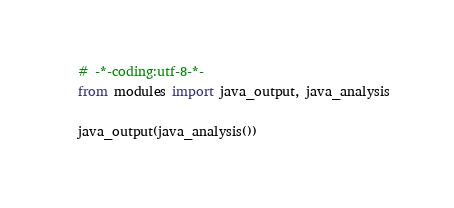Convert code to text. <code><loc_0><loc_0><loc_500><loc_500><_Python_># -*-coding:utf-8-*-
from modules import java_output, java_analysis

java_output(java_analysis())
</code> 